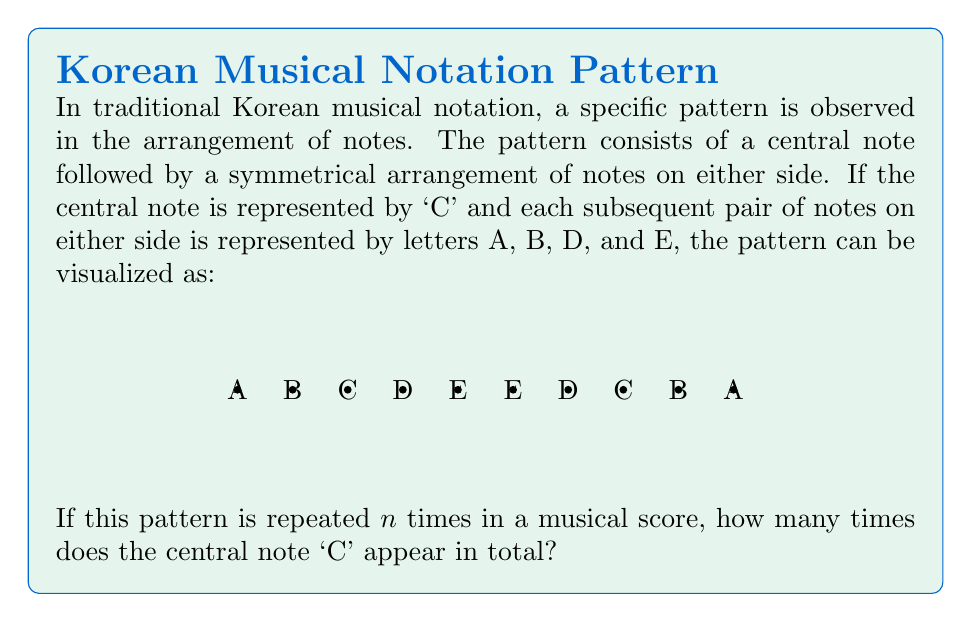Help me with this question. Let's approach this step-by-step:

1) First, we need to understand the structure of the pattern:
   - The pattern is symmetrical around the central 'C'.
   - The full pattern is: A B C D E E D C B A

2) We can see that 'C' appears twice in each full pattern:
   - Once as the central note
   - Once as part of the symmetrical arrangement

3) Now, let's consider the repetition:
   - If the pattern is repeated $n$ times, we might think the answer is simply $2n$.

4) However, we need to account for an important detail:
   - When the pattern repeats, the last 'A' of one pattern is immediately followed by the first 'A' of the next pattern.
   - This means that the central 'C' at the end of one pattern becomes the start of the next pattern.

5) As a result:
   - For $n$ repetitions, we don't count the 'C' at the end of each pattern (except for the last one).
   - The number of 'C's will be: $n + 1$

6) Therefore, the total number of times 'C' appears is $n + 1$.
Answer: $n + 1$ 